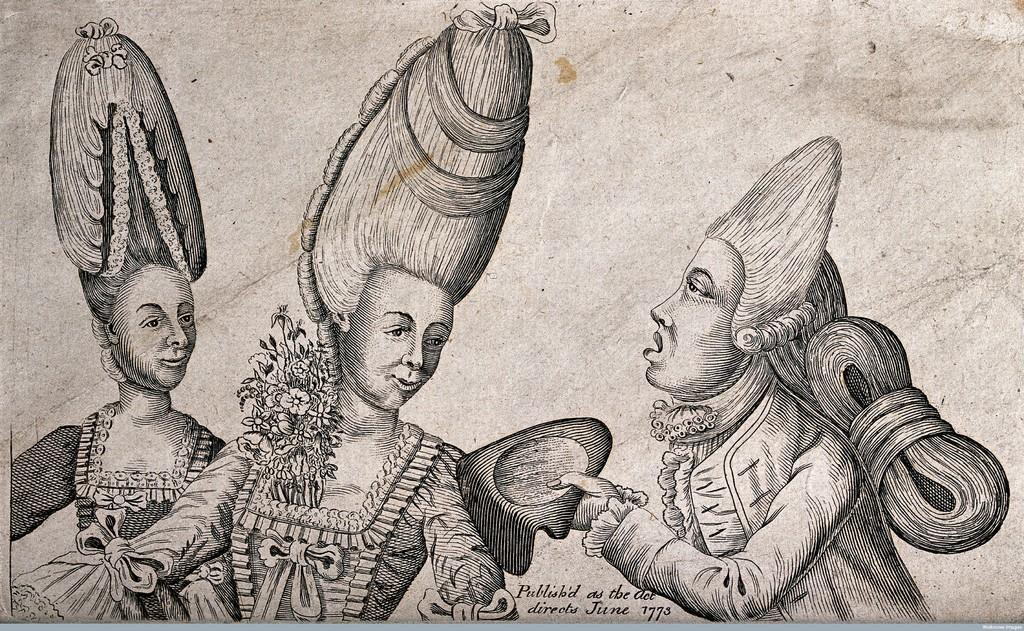What type of image is being described? The image is a drawing. How many people are depicted in the drawing? There are three people in the drawing. Is there any additional information provided with the drawing? Yes, there is some information mentioned below the drawing. Reasoning: Let's think step by breaking down the conversation step by step. We start by identifying the type of image, which is a drawing. Then, we focus on the number of people in the drawing, which is three. Finally, we mention the presence of additional information below the drawing. Each question is designed to provide a clear and concise answer based on the provided facts. Absurd Question/Answer: What type of event is the zebra participating in within the drawing? There is no zebra present in the drawing, so it cannot be participating in any event. 